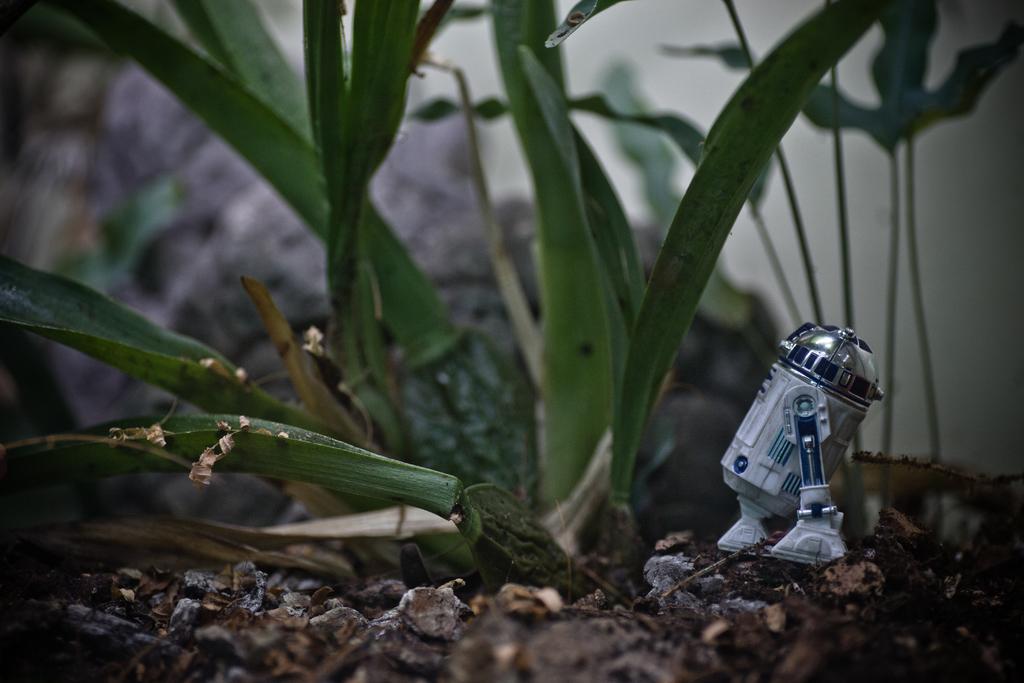Please provide a concise description of this image. This image consists of a plant. At the bottom, there are dried leaves on the ground. On the right, there is an object. It looks like a toy robot. 